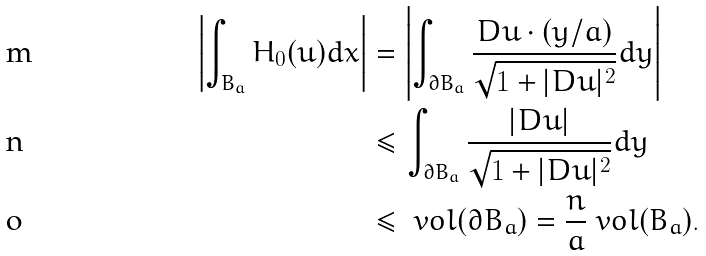<formula> <loc_0><loc_0><loc_500><loc_500>\left | \int _ { B _ { a } } H _ { 0 } ( u ) d x \right | & = \left | \int _ { \partial B _ { a } } \frac { D u \cdot ( y / a ) } { \sqrt { 1 + | D u | ^ { 2 } } } d y \right | \\ & \leq \int _ { \partial B _ { a } } \frac { | D u | } { \sqrt { 1 + | D u | ^ { 2 } } } d y \\ & \leq \ v o l ( \partial B _ { a } ) = \frac { n } { a } \ v o l ( B _ { a } ) .</formula> 